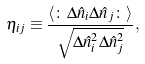Convert formula to latex. <formula><loc_0><loc_0><loc_500><loc_500>\eta _ { i j } \equiv \frac { \langle \colon \Delta \hat { n } _ { i } \Delta \hat { n } _ { j } \colon \rangle } { \sqrt { \Delta \hat { n } _ { i } ^ { 2 } \Delta \hat { n } _ { j } ^ { 2 } } } ,</formula> 